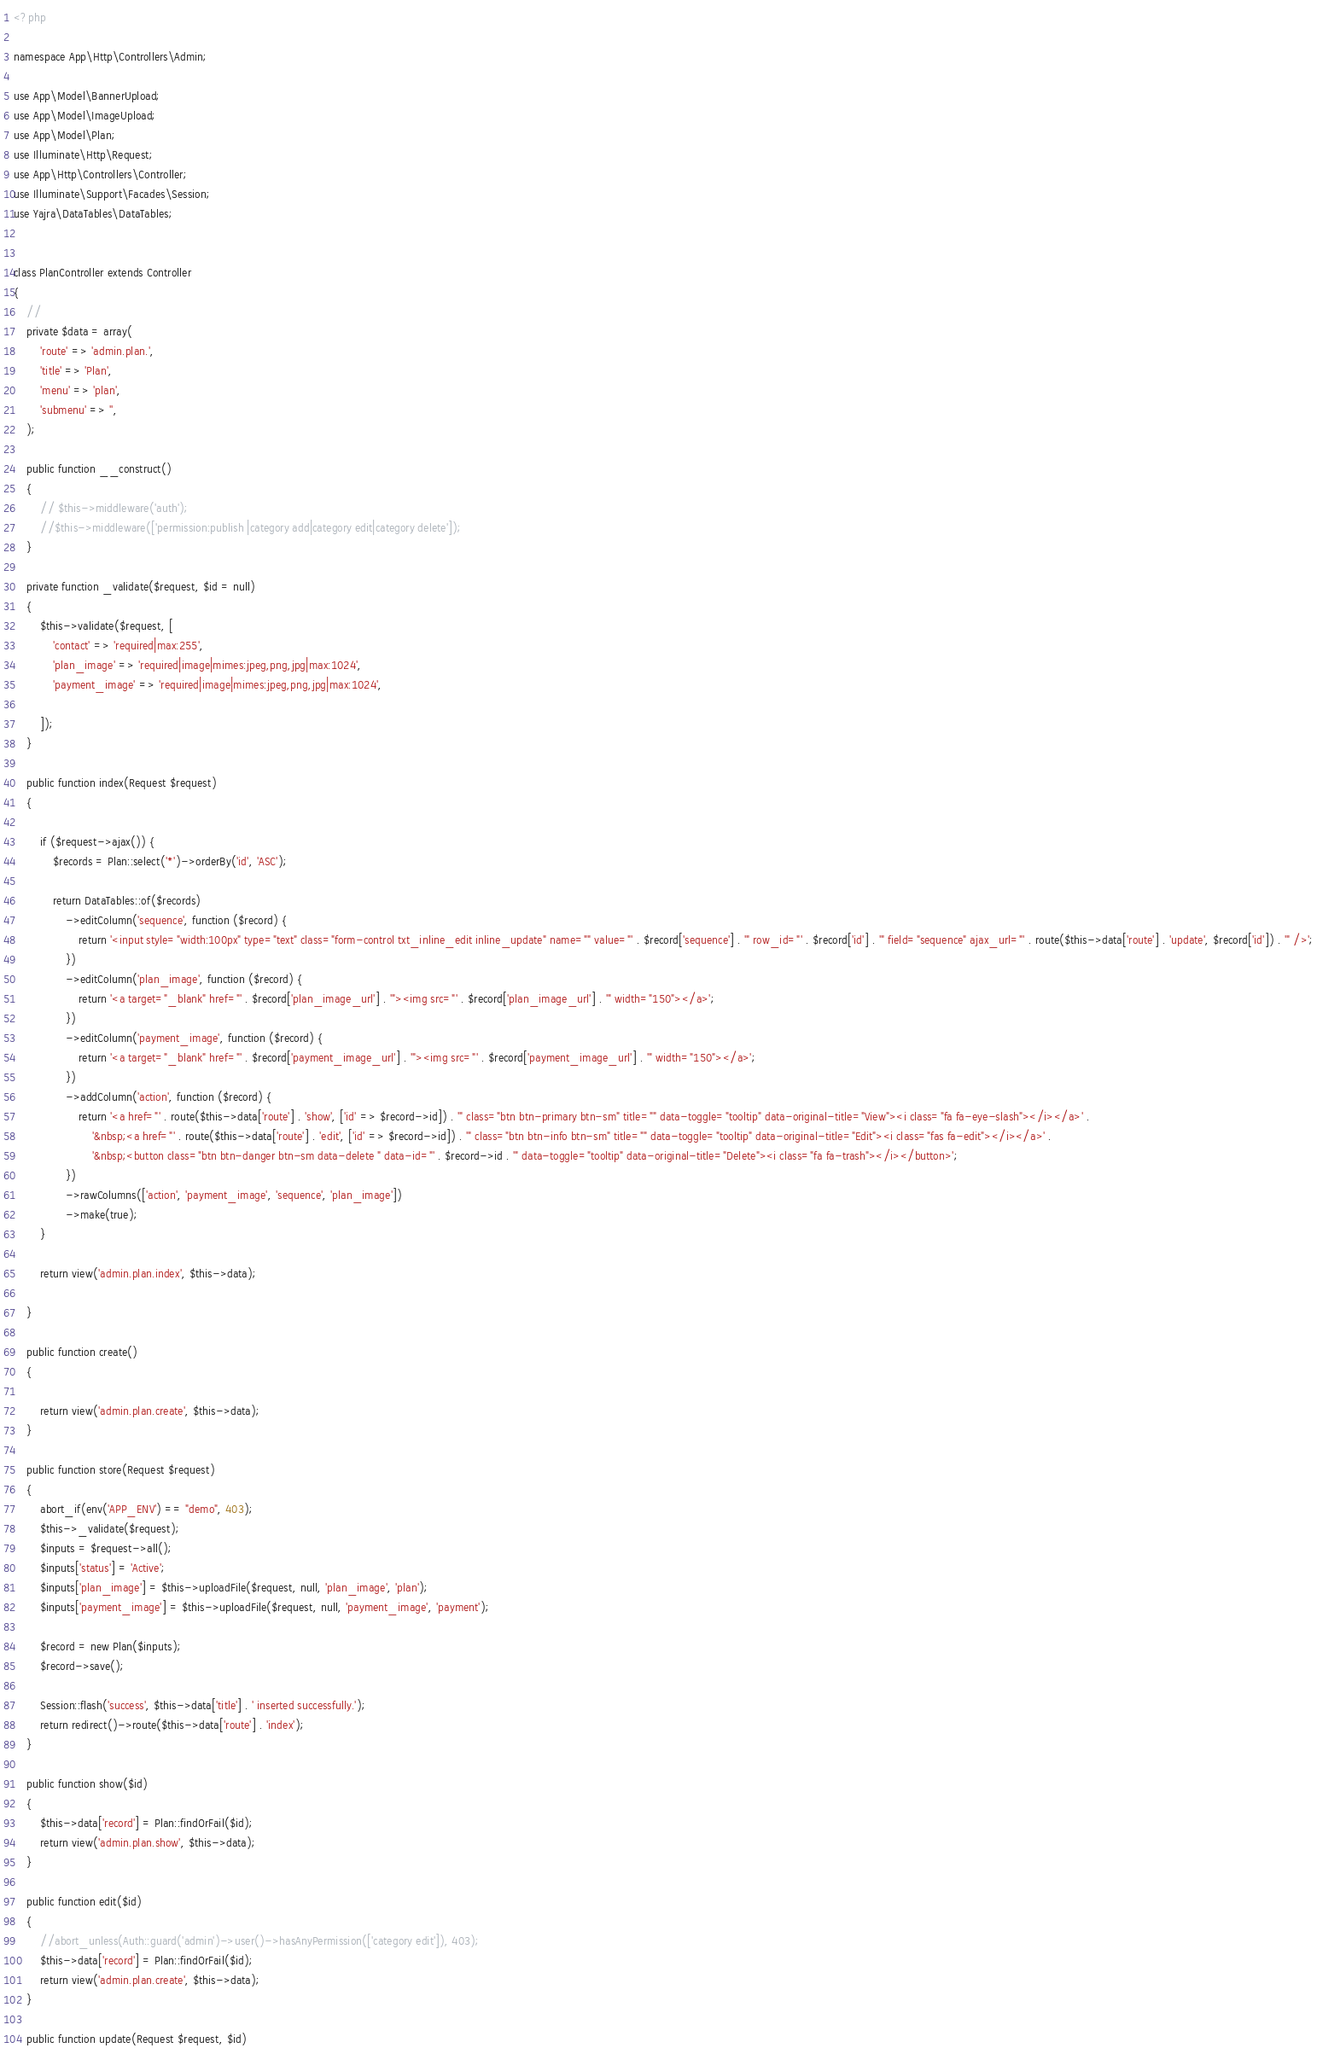Convert code to text. <code><loc_0><loc_0><loc_500><loc_500><_PHP_><?php

namespace App\Http\Controllers\Admin;

use App\Model\BannerUpload;
use App\Model\ImageUpload;
use App\Model\Plan;
use Illuminate\Http\Request;
use App\Http\Controllers\Controller;
use Illuminate\Support\Facades\Session;
use Yajra\DataTables\DataTables;


class PlanController extends Controller
{
    //
    private $data = array(
        'route' => 'admin.plan.',
        'title' => 'Plan',
        'menu' => 'plan',
        'submenu' => '',
    );

    public function __construct()
    {
        // $this->middleware('auth');
        //$this->middleware(['permission:publish |category add|category edit|category delete']);
    }

    private function _validate($request, $id = null)
    {
        $this->validate($request, [
            'contact' => 'required|max:255',
            'plan_image' => 'required|image|mimes:jpeg,png,jpg|max:1024',
            'payment_image' => 'required|image|mimes:jpeg,png,jpg|max:1024',

        ]);
    }

    public function index(Request $request)
    {

        if ($request->ajax()) {
            $records = Plan::select('*')->orderBy('id', 'ASC');

            return DataTables::of($records)
                ->editColumn('sequence', function ($record) {
                    return '<input style="width:100px" type="text" class="form-control txt_inline_edit inline_update" name="" value="' . $record['sequence'] . '" row_id="' . $record['id'] . '" field="sequence" ajax_url="' . route($this->data['route'] . 'update', $record['id']) . '" />';
                })
                ->editColumn('plan_image', function ($record) {
                    return '<a target="_blank" href="' . $record['plan_image_url'] . '"><img src="' . $record['plan_image_url'] . '" width="150"></a>';
                })
                ->editColumn('payment_image', function ($record) {
                    return '<a target="_blank" href="' . $record['payment_image_url'] . '"><img src="' . $record['payment_image_url'] . '" width="150"></a>';
                })
                ->addColumn('action', function ($record) {
                    return '<a href="' . route($this->data['route'] . 'show', ['id' => $record->id]) . '" class="btn btn-primary btn-sm" title="" data-toggle="tooltip" data-original-title="View"><i class="fa fa-eye-slash"></i></a>' .
                        '&nbsp;<a href="' . route($this->data['route'] . 'edit', ['id' => $record->id]) . '" class="btn btn-info btn-sm" title="" data-toggle="tooltip" data-original-title="Edit"><i class="fas fa-edit"></i></a>' .
                        '&nbsp;<button class="btn btn-danger btn-sm data-delete " data-id="' . $record->id . '" data-toggle="tooltip" data-original-title="Delete"><i class="fa fa-trash"></i></button>';
                })
                ->rawColumns(['action', 'payment_image', 'sequence', 'plan_image'])
                ->make(true);
        }

        return view('admin.plan.index', $this->data);

    }

    public function create()
    {

        return view('admin.plan.create', $this->data);
    }

    public function store(Request $request)
    {
        abort_if(env('APP_ENV') == "demo", 403);
        $this->_validate($request);
        $inputs = $request->all();
        $inputs['status'] = 'Active';
        $inputs['plan_image'] = $this->uploadFile($request, null, 'plan_image', 'plan');
        $inputs['payment_image'] = $this->uploadFile($request, null, 'payment_image', 'payment');

        $record = new Plan($inputs);
        $record->save();

        Session::flash('success', $this->data['title'] . ' inserted successfully.');
        return redirect()->route($this->data['route'] . 'index');
    }

    public function show($id)
    {
        $this->data['record'] = Plan::findOrFail($id);
        return view('admin.plan.show', $this->data);
    }

    public function edit($id)
    {
        //abort_unless(Auth::guard('admin')->user()->hasAnyPermission(['category edit']), 403);
        $this->data['record'] = Plan::findOrFail($id);
        return view('admin.plan.create', $this->data);
    }

    public function update(Request $request, $id)</code> 